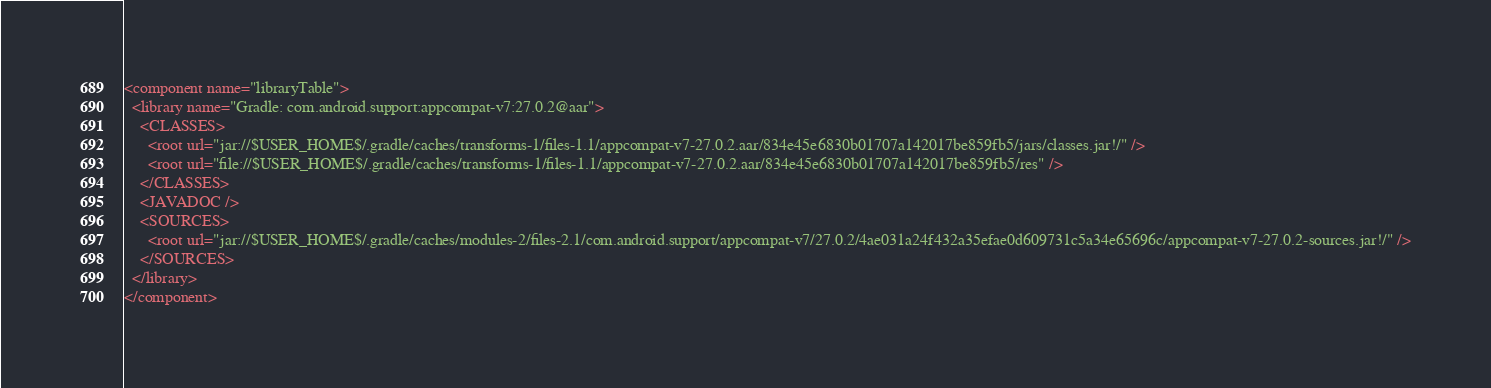Convert code to text. <code><loc_0><loc_0><loc_500><loc_500><_XML_><component name="libraryTable">
  <library name="Gradle: com.android.support:appcompat-v7:27.0.2@aar">
    <CLASSES>
      <root url="jar://$USER_HOME$/.gradle/caches/transforms-1/files-1.1/appcompat-v7-27.0.2.aar/834e45e6830b01707a142017be859fb5/jars/classes.jar!/" />
      <root url="file://$USER_HOME$/.gradle/caches/transforms-1/files-1.1/appcompat-v7-27.0.2.aar/834e45e6830b01707a142017be859fb5/res" />
    </CLASSES>
    <JAVADOC />
    <SOURCES>
      <root url="jar://$USER_HOME$/.gradle/caches/modules-2/files-2.1/com.android.support/appcompat-v7/27.0.2/4ae031a24f432a35efae0d609731c5a34e65696c/appcompat-v7-27.0.2-sources.jar!/" />
    </SOURCES>
  </library>
</component></code> 